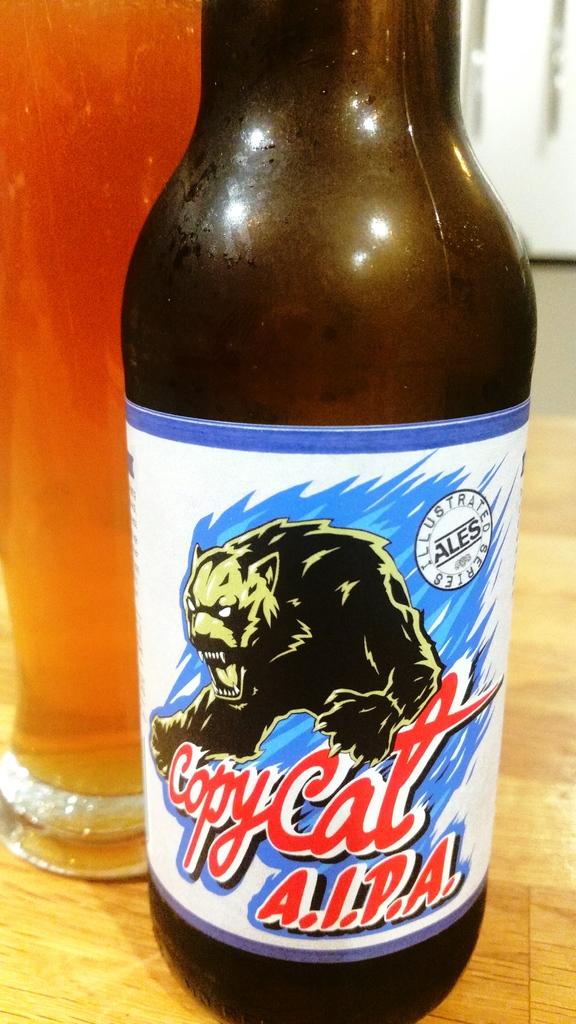What is the name of the beer?
Offer a terse response. Copycat a.i.p.a. 